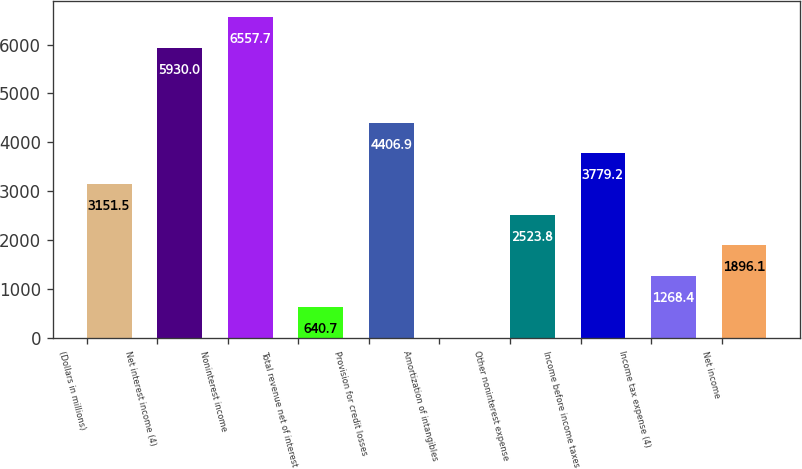Convert chart to OTSL. <chart><loc_0><loc_0><loc_500><loc_500><bar_chart><fcel>(Dollars in millions)<fcel>Net interest income (4)<fcel>Noninterest income<fcel>Total revenue net of interest<fcel>Provision for credit losses<fcel>Amortization of intangibles<fcel>Other noninterest expense<fcel>Income before income taxes<fcel>Income tax expense (4)<fcel>Net income<nl><fcel>3151.5<fcel>5930<fcel>6557.7<fcel>640.7<fcel>4406.9<fcel>13<fcel>2523.8<fcel>3779.2<fcel>1268.4<fcel>1896.1<nl></chart> 